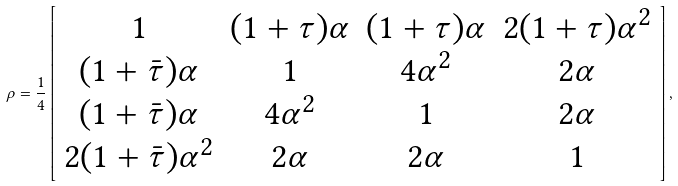Convert formula to latex. <formula><loc_0><loc_0><loc_500><loc_500>\rho = \frac { 1 } { 4 } \left [ \begin{array} { c c c c } 1 & ( 1 + \tau ) \alpha & ( 1 + \tau ) \alpha & 2 ( 1 + \tau ) \alpha ^ { 2 } \\ ( 1 + \bar { \tau } ) \alpha & 1 & 4 \alpha ^ { 2 } & 2 \alpha \\ ( 1 + \bar { \tau } ) \alpha & 4 \alpha ^ { 2 } & 1 & 2 \alpha \\ 2 ( 1 + \bar { \tau } ) \alpha ^ { 2 } & 2 \alpha & 2 \alpha & 1 \\ \end{array} \right ] ,</formula> 